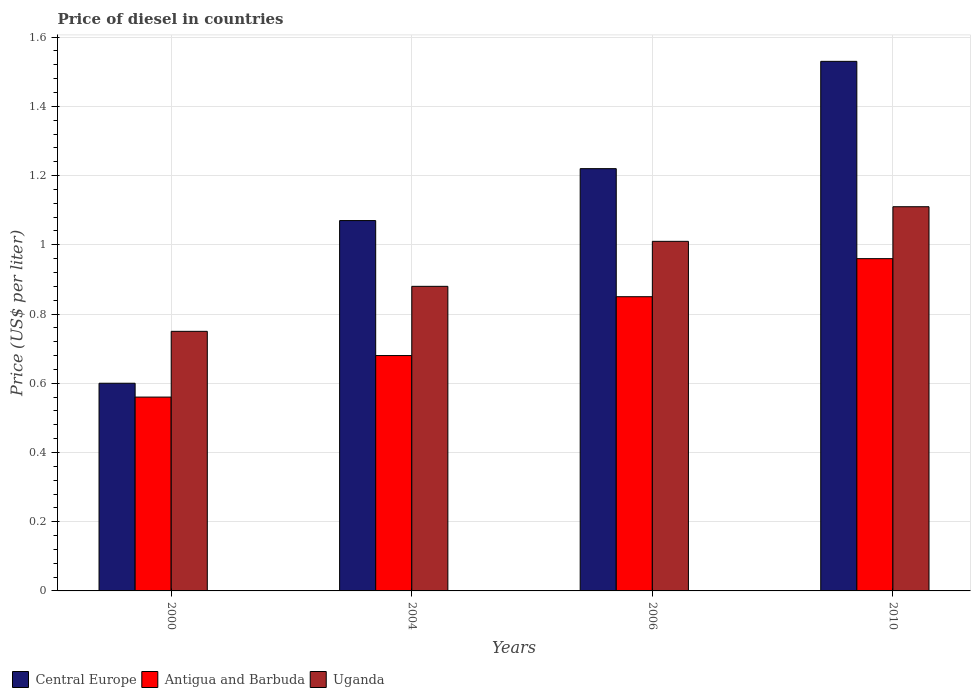In how many cases, is the number of bars for a given year not equal to the number of legend labels?
Offer a terse response. 0. What is the price of diesel in Antigua and Barbuda in 2004?
Offer a very short reply. 0.68. Across all years, what is the minimum price of diesel in Uganda?
Make the answer very short. 0.75. In which year was the price of diesel in Antigua and Barbuda minimum?
Your answer should be very brief. 2000. What is the total price of diesel in Antigua and Barbuda in the graph?
Offer a terse response. 3.05. What is the difference between the price of diesel in Antigua and Barbuda in 2004 and that in 2006?
Your answer should be compact. -0.17. What is the difference between the price of diesel in Central Europe in 2006 and the price of diesel in Uganda in 2004?
Ensure brevity in your answer.  0.34. What is the average price of diesel in Uganda per year?
Your answer should be very brief. 0.94. In the year 2004, what is the difference between the price of diesel in Uganda and price of diesel in Antigua and Barbuda?
Your answer should be compact. 0.2. What is the ratio of the price of diesel in Uganda in 2000 to that in 2006?
Provide a short and direct response. 0.74. Is the price of diesel in Central Europe in 2000 less than that in 2006?
Provide a succinct answer. Yes. What is the difference between the highest and the second highest price of diesel in Central Europe?
Provide a succinct answer. 0.31. In how many years, is the price of diesel in Antigua and Barbuda greater than the average price of diesel in Antigua and Barbuda taken over all years?
Make the answer very short. 2. What does the 3rd bar from the left in 2004 represents?
Provide a short and direct response. Uganda. What does the 2nd bar from the right in 2000 represents?
Provide a short and direct response. Antigua and Barbuda. Is it the case that in every year, the sum of the price of diesel in Uganda and price of diesel in Central Europe is greater than the price of diesel in Antigua and Barbuda?
Make the answer very short. Yes. How many bars are there?
Give a very brief answer. 12. Are all the bars in the graph horizontal?
Your response must be concise. No. How many years are there in the graph?
Your answer should be compact. 4. Are the values on the major ticks of Y-axis written in scientific E-notation?
Provide a succinct answer. No. How many legend labels are there?
Keep it short and to the point. 3. How are the legend labels stacked?
Your answer should be compact. Horizontal. What is the title of the graph?
Give a very brief answer. Price of diesel in countries. What is the label or title of the X-axis?
Make the answer very short. Years. What is the label or title of the Y-axis?
Offer a very short reply. Price (US$ per liter). What is the Price (US$ per liter) in Central Europe in 2000?
Your response must be concise. 0.6. What is the Price (US$ per liter) in Antigua and Barbuda in 2000?
Make the answer very short. 0.56. What is the Price (US$ per liter) of Uganda in 2000?
Provide a succinct answer. 0.75. What is the Price (US$ per liter) in Central Europe in 2004?
Your response must be concise. 1.07. What is the Price (US$ per liter) in Antigua and Barbuda in 2004?
Give a very brief answer. 0.68. What is the Price (US$ per liter) of Uganda in 2004?
Your response must be concise. 0.88. What is the Price (US$ per liter) of Central Europe in 2006?
Your answer should be very brief. 1.22. What is the Price (US$ per liter) in Central Europe in 2010?
Make the answer very short. 1.53. What is the Price (US$ per liter) in Antigua and Barbuda in 2010?
Keep it short and to the point. 0.96. What is the Price (US$ per liter) of Uganda in 2010?
Offer a terse response. 1.11. Across all years, what is the maximum Price (US$ per liter) in Central Europe?
Offer a very short reply. 1.53. Across all years, what is the maximum Price (US$ per liter) of Uganda?
Ensure brevity in your answer.  1.11. Across all years, what is the minimum Price (US$ per liter) of Antigua and Barbuda?
Your response must be concise. 0.56. What is the total Price (US$ per liter) of Central Europe in the graph?
Make the answer very short. 4.42. What is the total Price (US$ per liter) of Antigua and Barbuda in the graph?
Offer a terse response. 3.05. What is the total Price (US$ per liter) in Uganda in the graph?
Make the answer very short. 3.75. What is the difference between the Price (US$ per liter) in Central Europe in 2000 and that in 2004?
Keep it short and to the point. -0.47. What is the difference between the Price (US$ per liter) in Antigua and Barbuda in 2000 and that in 2004?
Ensure brevity in your answer.  -0.12. What is the difference between the Price (US$ per liter) in Uganda in 2000 and that in 2004?
Provide a succinct answer. -0.13. What is the difference between the Price (US$ per liter) in Central Europe in 2000 and that in 2006?
Your response must be concise. -0.62. What is the difference between the Price (US$ per liter) in Antigua and Barbuda in 2000 and that in 2006?
Provide a short and direct response. -0.29. What is the difference between the Price (US$ per liter) of Uganda in 2000 and that in 2006?
Offer a very short reply. -0.26. What is the difference between the Price (US$ per liter) in Central Europe in 2000 and that in 2010?
Offer a very short reply. -0.93. What is the difference between the Price (US$ per liter) in Antigua and Barbuda in 2000 and that in 2010?
Your answer should be compact. -0.4. What is the difference between the Price (US$ per liter) in Uganda in 2000 and that in 2010?
Provide a succinct answer. -0.36. What is the difference between the Price (US$ per liter) of Central Europe in 2004 and that in 2006?
Make the answer very short. -0.15. What is the difference between the Price (US$ per liter) in Antigua and Barbuda in 2004 and that in 2006?
Offer a terse response. -0.17. What is the difference between the Price (US$ per liter) of Uganda in 2004 and that in 2006?
Provide a short and direct response. -0.13. What is the difference between the Price (US$ per liter) in Central Europe in 2004 and that in 2010?
Ensure brevity in your answer.  -0.46. What is the difference between the Price (US$ per liter) in Antigua and Barbuda in 2004 and that in 2010?
Keep it short and to the point. -0.28. What is the difference between the Price (US$ per liter) of Uganda in 2004 and that in 2010?
Offer a very short reply. -0.23. What is the difference between the Price (US$ per liter) of Central Europe in 2006 and that in 2010?
Provide a succinct answer. -0.31. What is the difference between the Price (US$ per liter) in Antigua and Barbuda in 2006 and that in 2010?
Offer a very short reply. -0.11. What is the difference between the Price (US$ per liter) in Central Europe in 2000 and the Price (US$ per liter) in Antigua and Barbuda in 2004?
Offer a terse response. -0.08. What is the difference between the Price (US$ per liter) in Central Europe in 2000 and the Price (US$ per liter) in Uganda in 2004?
Your response must be concise. -0.28. What is the difference between the Price (US$ per liter) in Antigua and Barbuda in 2000 and the Price (US$ per liter) in Uganda in 2004?
Your answer should be very brief. -0.32. What is the difference between the Price (US$ per liter) of Central Europe in 2000 and the Price (US$ per liter) of Uganda in 2006?
Offer a very short reply. -0.41. What is the difference between the Price (US$ per liter) in Antigua and Barbuda in 2000 and the Price (US$ per liter) in Uganda in 2006?
Your answer should be very brief. -0.45. What is the difference between the Price (US$ per liter) of Central Europe in 2000 and the Price (US$ per liter) of Antigua and Barbuda in 2010?
Offer a terse response. -0.36. What is the difference between the Price (US$ per liter) of Central Europe in 2000 and the Price (US$ per liter) of Uganda in 2010?
Provide a succinct answer. -0.51. What is the difference between the Price (US$ per liter) of Antigua and Barbuda in 2000 and the Price (US$ per liter) of Uganda in 2010?
Your answer should be very brief. -0.55. What is the difference between the Price (US$ per liter) in Central Europe in 2004 and the Price (US$ per liter) in Antigua and Barbuda in 2006?
Give a very brief answer. 0.22. What is the difference between the Price (US$ per liter) in Central Europe in 2004 and the Price (US$ per liter) in Uganda in 2006?
Your answer should be very brief. 0.06. What is the difference between the Price (US$ per liter) of Antigua and Barbuda in 2004 and the Price (US$ per liter) of Uganda in 2006?
Ensure brevity in your answer.  -0.33. What is the difference between the Price (US$ per liter) of Central Europe in 2004 and the Price (US$ per liter) of Antigua and Barbuda in 2010?
Your response must be concise. 0.11. What is the difference between the Price (US$ per liter) of Central Europe in 2004 and the Price (US$ per liter) of Uganda in 2010?
Keep it short and to the point. -0.04. What is the difference between the Price (US$ per liter) in Antigua and Barbuda in 2004 and the Price (US$ per liter) in Uganda in 2010?
Keep it short and to the point. -0.43. What is the difference between the Price (US$ per liter) in Central Europe in 2006 and the Price (US$ per liter) in Antigua and Barbuda in 2010?
Provide a short and direct response. 0.26. What is the difference between the Price (US$ per liter) of Central Europe in 2006 and the Price (US$ per liter) of Uganda in 2010?
Provide a succinct answer. 0.11. What is the difference between the Price (US$ per liter) in Antigua and Barbuda in 2006 and the Price (US$ per liter) in Uganda in 2010?
Make the answer very short. -0.26. What is the average Price (US$ per liter) of Central Europe per year?
Offer a terse response. 1.1. What is the average Price (US$ per liter) in Antigua and Barbuda per year?
Give a very brief answer. 0.76. In the year 2000, what is the difference between the Price (US$ per liter) of Central Europe and Price (US$ per liter) of Antigua and Barbuda?
Your answer should be very brief. 0.04. In the year 2000, what is the difference between the Price (US$ per liter) in Antigua and Barbuda and Price (US$ per liter) in Uganda?
Offer a terse response. -0.19. In the year 2004, what is the difference between the Price (US$ per liter) of Central Europe and Price (US$ per liter) of Antigua and Barbuda?
Provide a short and direct response. 0.39. In the year 2004, what is the difference between the Price (US$ per liter) in Central Europe and Price (US$ per liter) in Uganda?
Your answer should be very brief. 0.19. In the year 2004, what is the difference between the Price (US$ per liter) of Antigua and Barbuda and Price (US$ per liter) of Uganda?
Offer a terse response. -0.2. In the year 2006, what is the difference between the Price (US$ per liter) of Central Europe and Price (US$ per liter) of Antigua and Barbuda?
Ensure brevity in your answer.  0.37. In the year 2006, what is the difference between the Price (US$ per liter) of Central Europe and Price (US$ per liter) of Uganda?
Keep it short and to the point. 0.21. In the year 2006, what is the difference between the Price (US$ per liter) in Antigua and Barbuda and Price (US$ per liter) in Uganda?
Ensure brevity in your answer.  -0.16. In the year 2010, what is the difference between the Price (US$ per liter) of Central Europe and Price (US$ per liter) of Antigua and Barbuda?
Offer a very short reply. 0.57. In the year 2010, what is the difference between the Price (US$ per liter) of Central Europe and Price (US$ per liter) of Uganda?
Provide a short and direct response. 0.42. In the year 2010, what is the difference between the Price (US$ per liter) of Antigua and Barbuda and Price (US$ per liter) of Uganda?
Offer a terse response. -0.15. What is the ratio of the Price (US$ per liter) of Central Europe in 2000 to that in 2004?
Ensure brevity in your answer.  0.56. What is the ratio of the Price (US$ per liter) in Antigua and Barbuda in 2000 to that in 2004?
Your response must be concise. 0.82. What is the ratio of the Price (US$ per liter) of Uganda in 2000 to that in 2004?
Provide a short and direct response. 0.85. What is the ratio of the Price (US$ per liter) in Central Europe in 2000 to that in 2006?
Give a very brief answer. 0.49. What is the ratio of the Price (US$ per liter) of Antigua and Barbuda in 2000 to that in 2006?
Your answer should be very brief. 0.66. What is the ratio of the Price (US$ per liter) in Uganda in 2000 to that in 2006?
Provide a short and direct response. 0.74. What is the ratio of the Price (US$ per liter) in Central Europe in 2000 to that in 2010?
Provide a short and direct response. 0.39. What is the ratio of the Price (US$ per liter) in Antigua and Barbuda in 2000 to that in 2010?
Make the answer very short. 0.58. What is the ratio of the Price (US$ per liter) in Uganda in 2000 to that in 2010?
Keep it short and to the point. 0.68. What is the ratio of the Price (US$ per liter) of Central Europe in 2004 to that in 2006?
Offer a very short reply. 0.88. What is the ratio of the Price (US$ per liter) in Antigua and Barbuda in 2004 to that in 2006?
Offer a terse response. 0.8. What is the ratio of the Price (US$ per liter) in Uganda in 2004 to that in 2006?
Give a very brief answer. 0.87. What is the ratio of the Price (US$ per liter) of Central Europe in 2004 to that in 2010?
Your answer should be very brief. 0.7. What is the ratio of the Price (US$ per liter) of Antigua and Barbuda in 2004 to that in 2010?
Keep it short and to the point. 0.71. What is the ratio of the Price (US$ per liter) of Uganda in 2004 to that in 2010?
Your answer should be very brief. 0.79. What is the ratio of the Price (US$ per liter) of Central Europe in 2006 to that in 2010?
Your answer should be compact. 0.8. What is the ratio of the Price (US$ per liter) in Antigua and Barbuda in 2006 to that in 2010?
Offer a very short reply. 0.89. What is the ratio of the Price (US$ per liter) in Uganda in 2006 to that in 2010?
Make the answer very short. 0.91. What is the difference between the highest and the second highest Price (US$ per liter) in Central Europe?
Offer a very short reply. 0.31. What is the difference between the highest and the second highest Price (US$ per liter) in Antigua and Barbuda?
Offer a very short reply. 0.11. What is the difference between the highest and the lowest Price (US$ per liter) in Central Europe?
Provide a short and direct response. 0.93. What is the difference between the highest and the lowest Price (US$ per liter) in Antigua and Barbuda?
Offer a terse response. 0.4. What is the difference between the highest and the lowest Price (US$ per liter) of Uganda?
Provide a succinct answer. 0.36. 